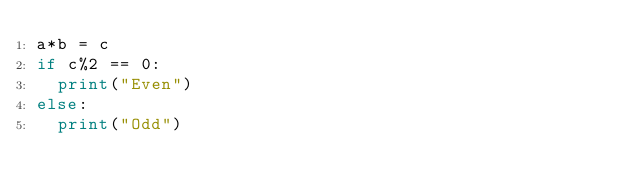<code> <loc_0><loc_0><loc_500><loc_500><_Python_>a*b = c
if c%2 == 0:
  print("Even")
else:
  print("Odd")</code> 